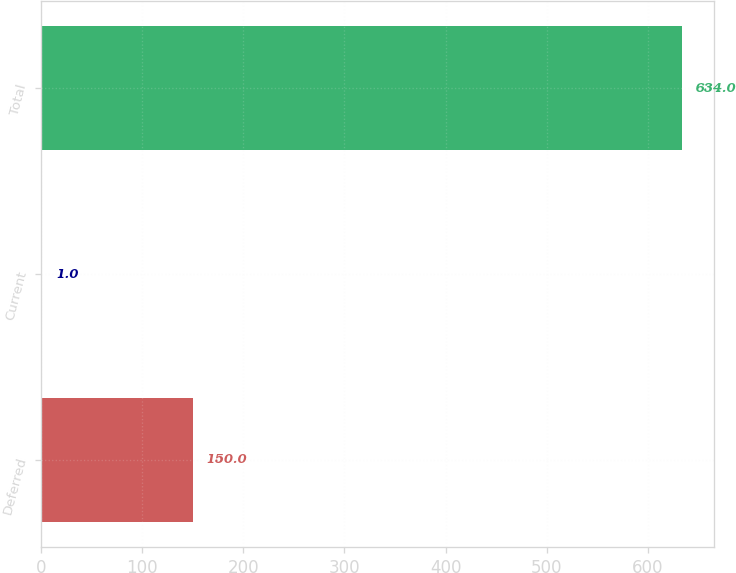<chart> <loc_0><loc_0><loc_500><loc_500><bar_chart><fcel>Deferred<fcel>Current<fcel>Total<nl><fcel>150<fcel>1<fcel>634<nl></chart> 